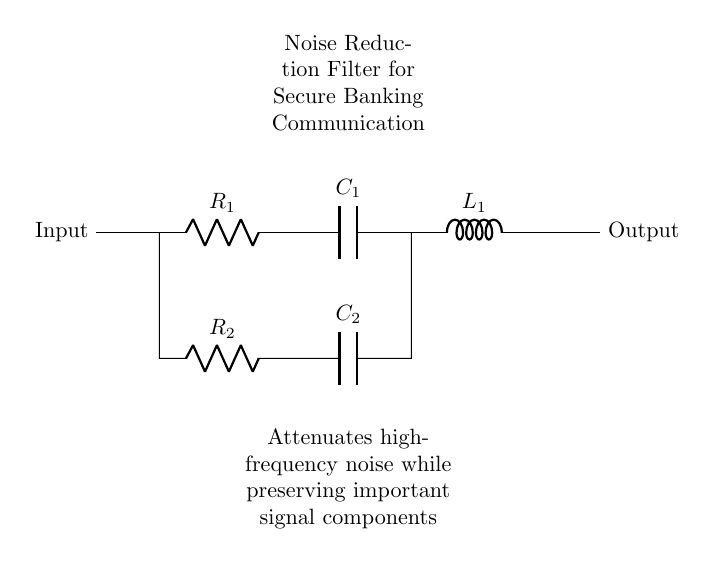What components are used in this noise reduction filter? The circuit contains two resistors (R1 and R2), two capacitors (C1 and C2), and one inductor (L1).
Answer: Resistors, capacitors, inductor What is the role of R2 in this circuit? R2 is part of a parallel connection with C2, helping to filter out specific noise frequencies from the signal.
Answer: To filter noise What type of filter does this circuit represent? This circuit is a noise reduction filter, specifically designed to attenuate high-frequency noise while preserving essential signal components.
Answer: Noise reduction filter How many capacitors are used in this circuit? The circuit contains two capacitors, C1 and C2, that work together to filter noise at different frequency levels.
Answer: Two What does the output represent in this diagram? The output is the filtered signal after processing through R1, C1, L1, and the parallel combination of R2 and C2, indicating that unwanted noise has been reduced.
Answer: Filtered signal Which component is responsible for attenuating high-frequency noise? The inductor L1 is primarily responsible for blocking or reducing high-frequency noise while allowing lower frequency signals to pass through.
Answer: Inductor What is the function of C1 in this circuit? C1 works in conjunction with L1 and R1 to provide a low-pass filtering effect, allowing required signals to pass while attenuating high-frequency noise.
Answer: Low-pass filtering 